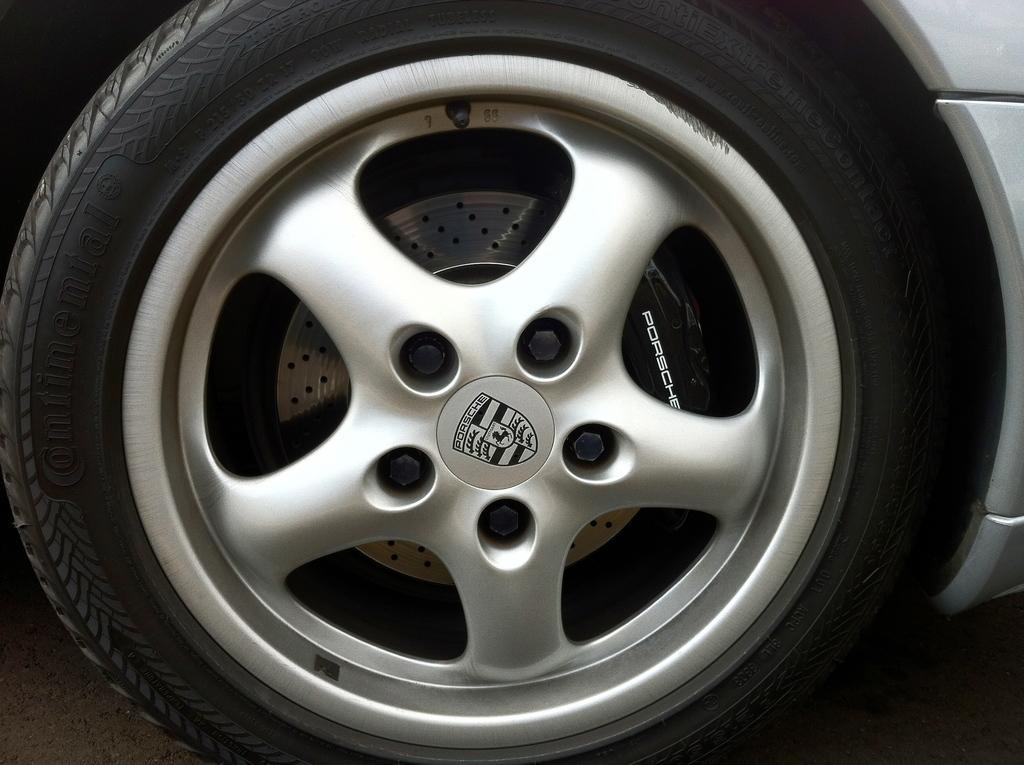Can you describe this image briefly? In this image, we can see vehicle wheel. Here we can see some text and symbol. On the right side of the image, there is a silver color object. At the bottom of the image, we can see the path. 